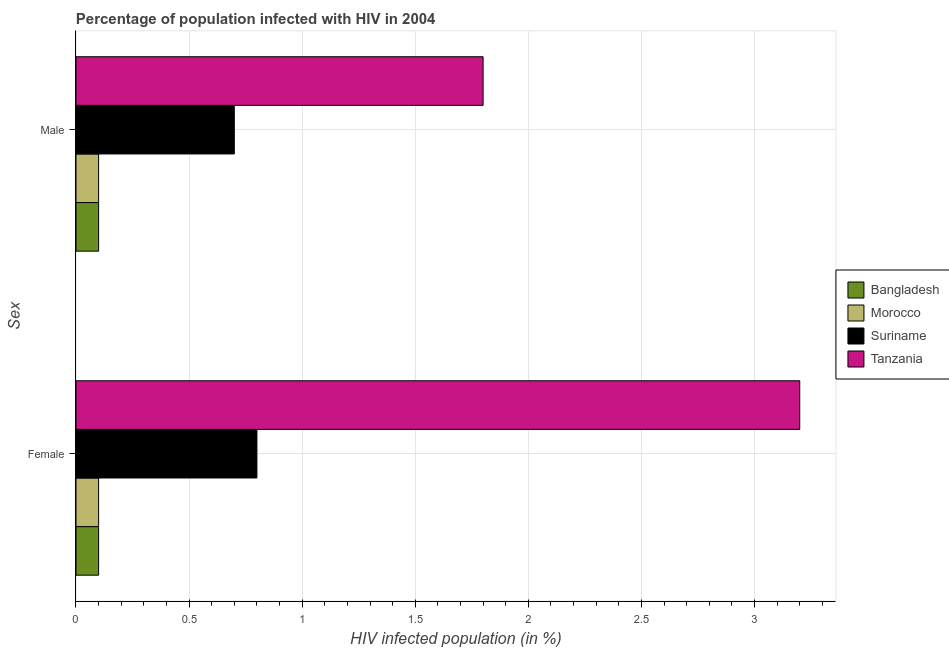How many different coloured bars are there?
Make the answer very short. 4. Are the number of bars per tick equal to the number of legend labels?
Provide a short and direct response. Yes. Are the number of bars on each tick of the Y-axis equal?
Keep it short and to the point. Yes. How many bars are there on the 2nd tick from the bottom?
Your answer should be very brief. 4. What is the label of the 1st group of bars from the top?
Offer a terse response. Male. What is the percentage of males who are infected with hiv in Bangladesh?
Provide a succinct answer. 0.1. Across all countries, what is the minimum percentage of males who are infected with hiv?
Provide a short and direct response. 0.1. In which country was the percentage of males who are infected with hiv maximum?
Offer a very short reply. Tanzania. What is the total percentage of males who are infected with hiv in the graph?
Offer a terse response. 2.7. What is the difference between the percentage of males who are infected with hiv in Bangladesh and that in Suriname?
Offer a terse response. -0.6. What is the difference between the percentage of males who are infected with hiv and percentage of females who are infected with hiv in Tanzania?
Provide a succinct answer. -1.4. What is the ratio of the percentage of males who are infected with hiv in Morocco to that in Suriname?
Ensure brevity in your answer.  0.14. Is the percentage of males who are infected with hiv in Bangladesh less than that in Tanzania?
Provide a succinct answer. Yes. What does the 1st bar from the top in Male represents?
Ensure brevity in your answer.  Tanzania. What does the 2nd bar from the bottom in Female represents?
Offer a terse response. Morocco. Are all the bars in the graph horizontal?
Provide a succinct answer. Yes. Are the values on the major ticks of X-axis written in scientific E-notation?
Keep it short and to the point. No. Does the graph contain any zero values?
Provide a succinct answer. No. Does the graph contain grids?
Keep it short and to the point. Yes. Where does the legend appear in the graph?
Your answer should be compact. Center right. How many legend labels are there?
Provide a short and direct response. 4. How are the legend labels stacked?
Keep it short and to the point. Vertical. What is the title of the graph?
Provide a succinct answer. Percentage of population infected with HIV in 2004. What is the label or title of the X-axis?
Offer a very short reply. HIV infected population (in %). What is the label or title of the Y-axis?
Your answer should be very brief. Sex. What is the HIV infected population (in %) of Suriname in Male?
Your answer should be very brief. 0.7. What is the HIV infected population (in %) of Tanzania in Male?
Provide a short and direct response. 1.8. Across all Sex, what is the maximum HIV infected population (in %) in Morocco?
Offer a terse response. 0.1. Across all Sex, what is the maximum HIV infected population (in %) of Tanzania?
Offer a very short reply. 3.2. What is the total HIV infected population (in %) in Bangladesh in the graph?
Your answer should be compact. 0.2. What is the total HIV infected population (in %) in Morocco in the graph?
Make the answer very short. 0.2. What is the total HIV infected population (in %) in Suriname in the graph?
Give a very brief answer. 1.5. What is the difference between the HIV infected population (in %) of Suriname in Female and that in Male?
Offer a terse response. 0.1. What is the difference between the HIV infected population (in %) of Bangladesh in Female and the HIV infected population (in %) of Suriname in Male?
Make the answer very short. -0.6. What is the difference between the HIV infected population (in %) in Bangladesh in Female and the HIV infected population (in %) in Tanzania in Male?
Your answer should be compact. -1.7. What is the difference between the HIV infected population (in %) of Morocco in Female and the HIV infected population (in %) of Suriname in Male?
Keep it short and to the point. -0.6. What is the difference between the HIV infected population (in %) of Morocco in Female and the HIV infected population (in %) of Tanzania in Male?
Your answer should be compact. -1.7. What is the average HIV infected population (in %) in Bangladesh per Sex?
Make the answer very short. 0.1. What is the average HIV infected population (in %) in Morocco per Sex?
Provide a succinct answer. 0.1. What is the difference between the HIV infected population (in %) in Bangladesh and HIV infected population (in %) in Tanzania in Female?
Ensure brevity in your answer.  -3.1. What is the difference between the HIV infected population (in %) of Morocco and HIV infected population (in %) of Suriname in Female?
Provide a succinct answer. -0.7. What is the difference between the HIV infected population (in %) in Morocco and HIV infected population (in %) in Tanzania in Female?
Offer a terse response. -3.1. What is the difference between the HIV infected population (in %) in Bangladesh and HIV infected population (in %) in Morocco in Male?
Your response must be concise. 0. What is the difference between the HIV infected population (in %) of Bangladesh and HIV infected population (in %) of Suriname in Male?
Your answer should be compact. -0.6. What is the difference between the HIV infected population (in %) in Morocco and HIV infected population (in %) in Suriname in Male?
Provide a succinct answer. -0.6. What is the difference between the HIV infected population (in %) of Suriname and HIV infected population (in %) of Tanzania in Male?
Make the answer very short. -1.1. What is the ratio of the HIV infected population (in %) of Morocco in Female to that in Male?
Offer a terse response. 1. What is the ratio of the HIV infected population (in %) in Tanzania in Female to that in Male?
Ensure brevity in your answer.  1.78. What is the difference between the highest and the second highest HIV infected population (in %) in Morocco?
Make the answer very short. 0. What is the difference between the highest and the lowest HIV infected population (in %) of Morocco?
Offer a very short reply. 0. What is the difference between the highest and the lowest HIV infected population (in %) of Suriname?
Your answer should be very brief. 0.1. What is the difference between the highest and the lowest HIV infected population (in %) of Tanzania?
Give a very brief answer. 1.4. 